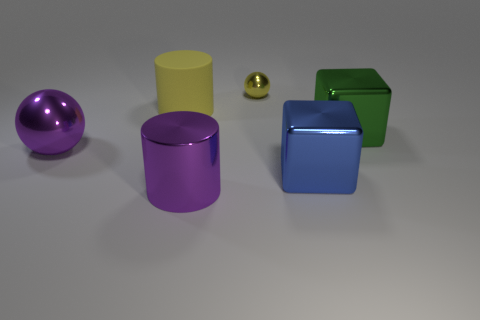Is there anything else that is the same material as the big yellow cylinder?
Provide a succinct answer. No. How many objects are either metal balls behind the yellow rubber object or tiny cyan shiny cubes?
Provide a succinct answer. 1. There is a big thing that is the same shape as the tiny yellow thing; what is its color?
Make the answer very short. Purple. There is a ball that is behind the purple sphere; how big is it?
Make the answer very short. Small. There is a rubber object; is its color the same as the tiny shiny thing that is behind the big blue metallic cube?
Your response must be concise. Yes. What number of other things are there of the same material as the large yellow cylinder
Your answer should be very brief. 0. Is the number of big cylinders greater than the number of tiny yellow metallic balls?
Provide a succinct answer. Yes. There is a ball behind the large sphere; is it the same color as the matte cylinder?
Offer a very short reply. Yes. The tiny sphere is what color?
Offer a terse response. Yellow. Is there a green metallic object behind the ball on the left side of the purple shiny cylinder?
Offer a very short reply. Yes. 